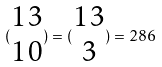<formula> <loc_0><loc_0><loc_500><loc_500>( \begin{matrix} 1 3 \\ 1 0 \end{matrix} ) = ( \begin{matrix} 1 3 \\ 3 \end{matrix} ) = 2 8 6</formula> 